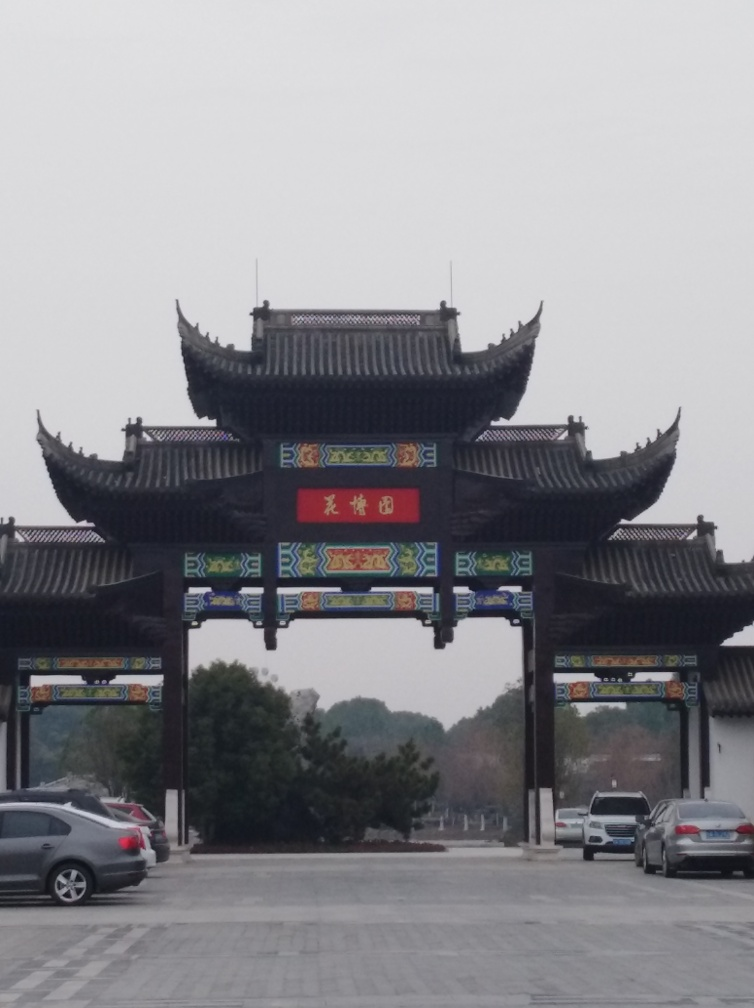Are there any quality issues with this image? The image appears to be a bit blurry and lacks sharpness, which affects the detail and crispness of the architectural features. Additionally, there's a noticeable tilt to the right, which throws off the balance of the composition. The overcast sky results in a flat lighting spectrum, thus reducing the visual impact of the colors, especially on the ornate signage and roof decorations. 